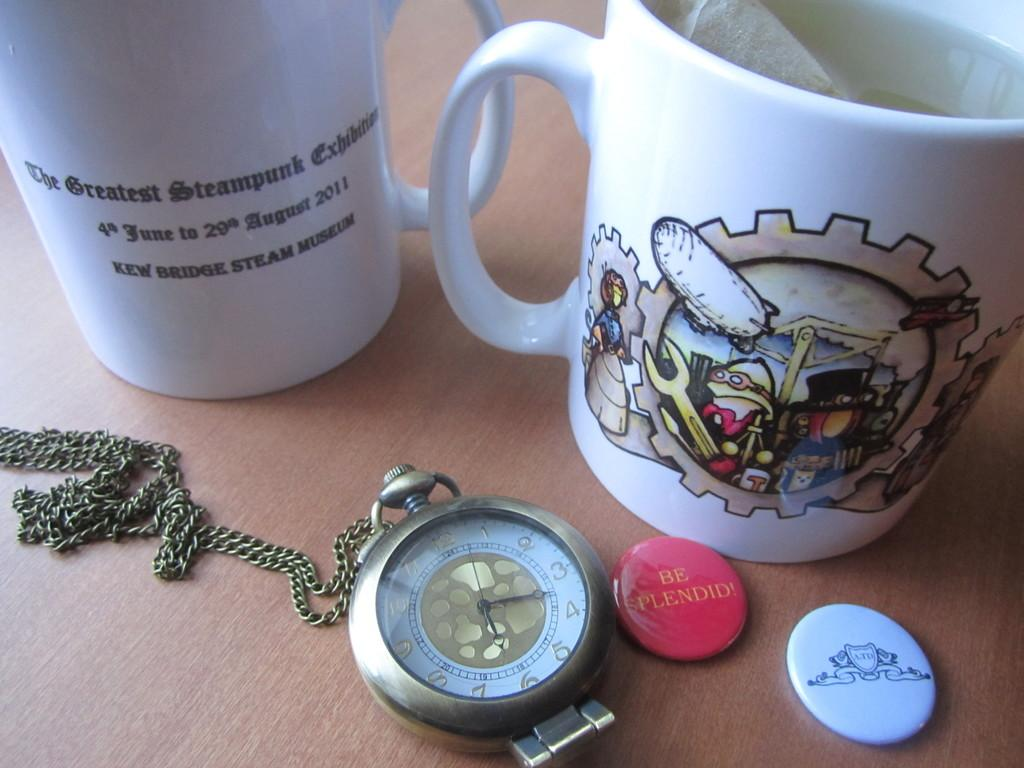<image>
Summarize the visual content of the image. A red button with the phrase Be Splendid written on it among a variety of items. 